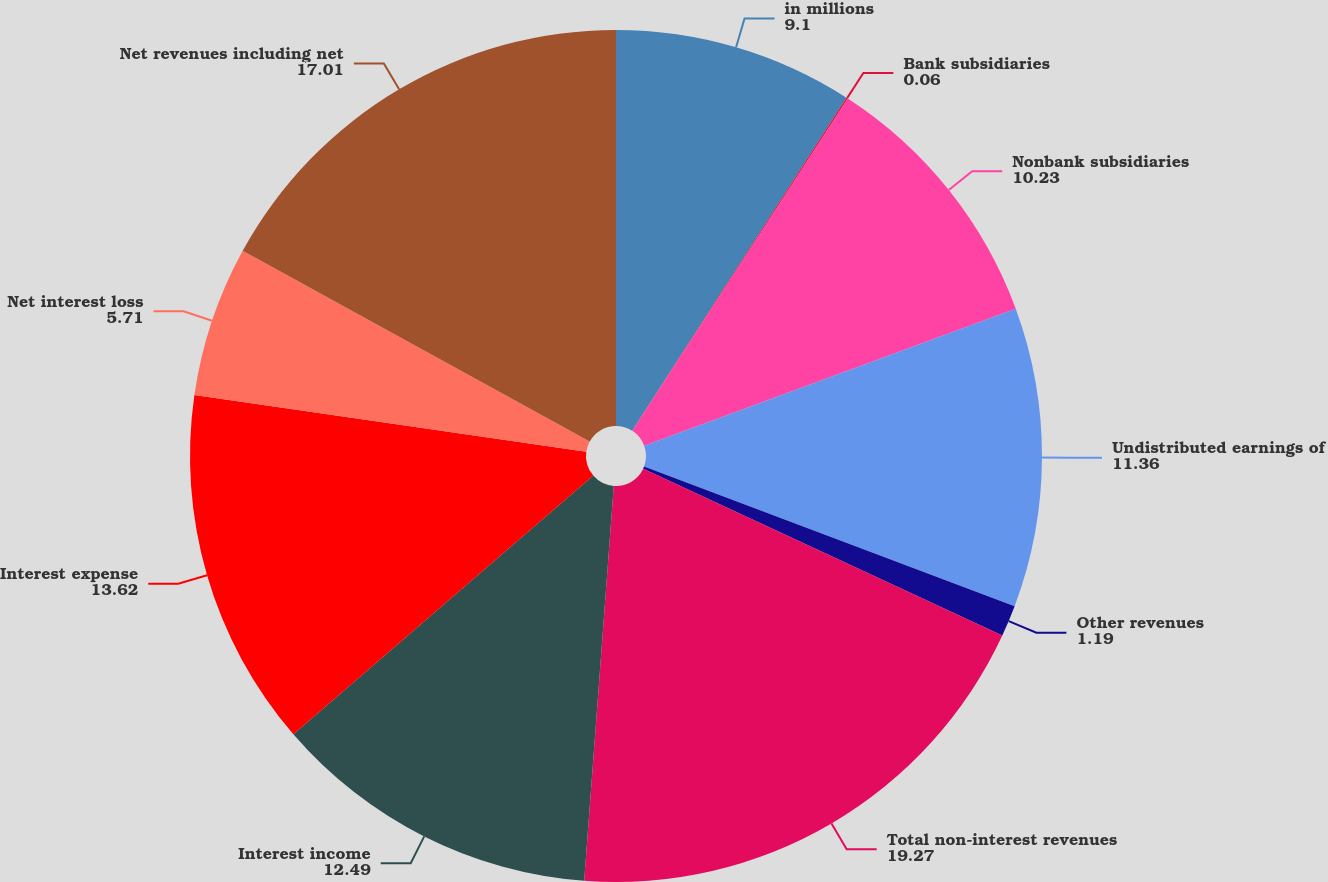Convert chart. <chart><loc_0><loc_0><loc_500><loc_500><pie_chart><fcel>in millions<fcel>Bank subsidiaries<fcel>Nonbank subsidiaries<fcel>Undistributed earnings of<fcel>Other revenues<fcel>Total non-interest revenues<fcel>Interest income<fcel>Interest expense<fcel>Net interest loss<fcel>Net revenues including net<nl><fcel>9.1%<fcel>0.06%<fcel>10.23%<fcel>11.36%<fcel>1.19%<fcel>19.27%<fcel>12.49%<fcel>13.62%<fcel>5.71%<fcel>17.01%<nl></chart> 